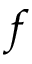Convert formula to latex. <formula><loc_0><loc_0><loc_500><loc_500>f</formula> 